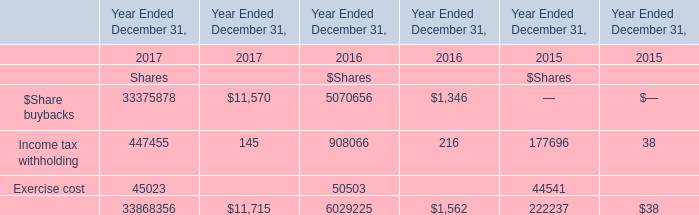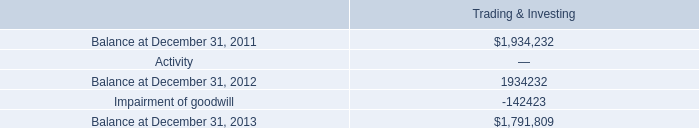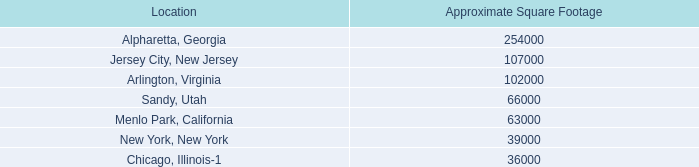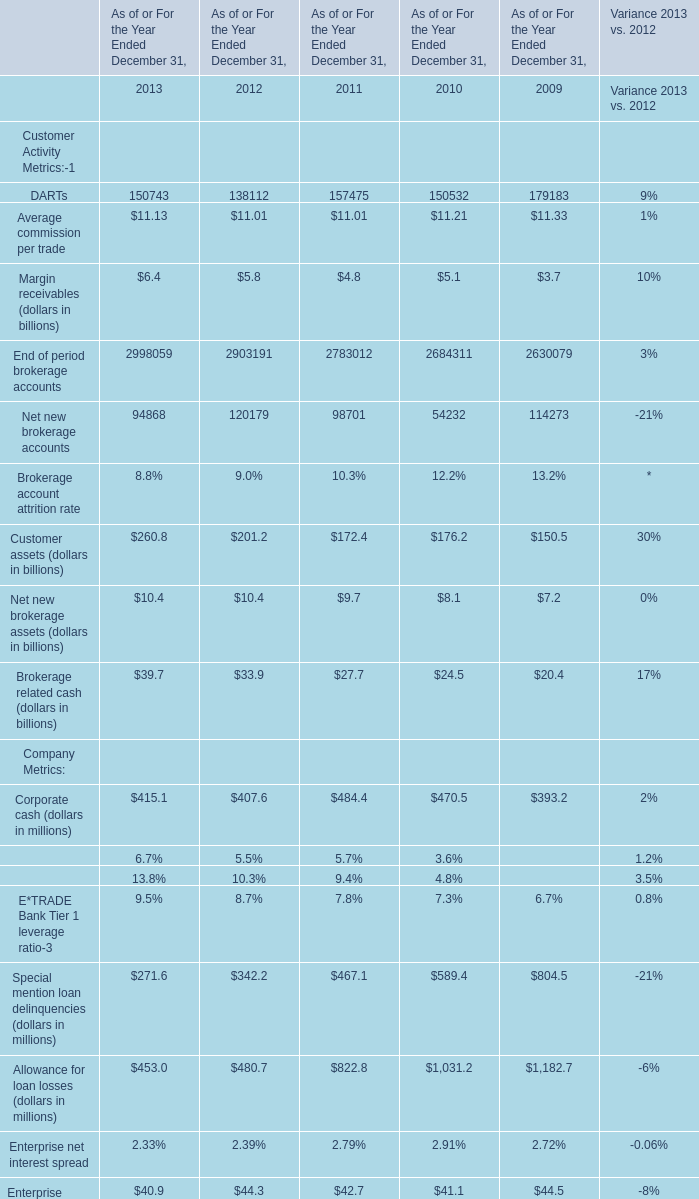In the year with the most Average commission per trade, what is the growth rate of Net new brokerage accounts? 
Computations: ((54232 - 114273) / 114273)
Answer: -0.52542. 